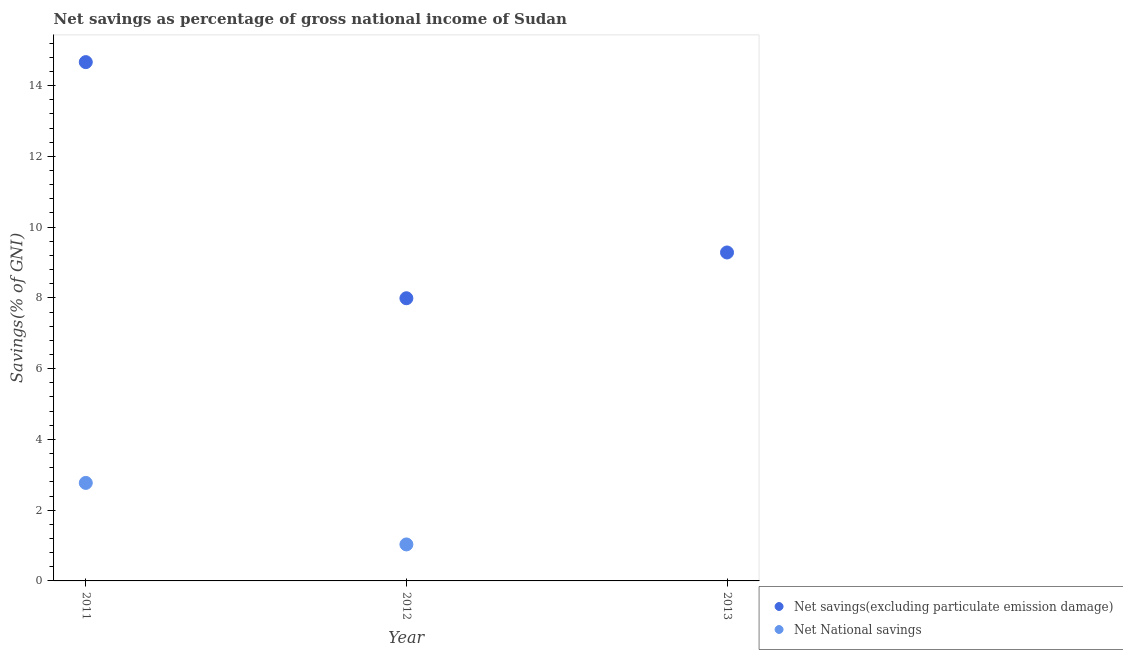What is the net national savings in 2013?
Keep it short and to the point. 0. Across all years, what is the maximum net savings(excluding particulate emission damage)?
Offer a very short reply. 14.66. Across all years, what is the minimum net savings(excluding particulate emission damage)?
Offer a terse response. 7.99. In which year was the net national savings maximum?
Make the answer very short. 2011. What is the total net national savings in the graph?
Your answer should be compact. 3.8. What is the difference between the net savings(excluding particulate emission damage) in 2011 and that in 2012?
Keep it short and to the point. 6.67. What is the difference between the net national savings in 2011 and the net savings(excluding particulate emission damage) in 2013?
Give a very brief answer. -6.51. What is the average net savings(excluding particulate emission damage) per year?
Your answer should be compact. 10.65. In the year 2012, what is the difference between the net savings(excluding particulate emission damage) and net national savings?
Your response must be concise. 6.96. In how many years, is the net national savings greater than 3.6 %?
Your answer should be very brief. 0. What is the ratio of the net savings(excluding particulate emission damage) in 2011 to that in 2012?
Your response must be concise. 1.84. Is the net national savings in 2011 less than that in 2012?
Provide a succinct answer. No. What is the difference between the highest and the second highest net savings(excluding particulate emission damage)?
Your answer should be very brief. 5.38. What is the difference between the highest and the lowest net national savings?
Your answer should be compact. 2.77. In how many years, is the net savings(excluding particulate emission damage) greater than the average net savings(excluding particulate emission damage) taken over all years?
Your answer should be very brief. 1. Is the sum of the net savings(excluding particulate emission damage) in 2011 and 2013 greater than the maximum net national savings across all years?
Offer a very short reply. Yes. Does the net national savings monotonically increase over the years?
Provide a short and direct response. No. Is the net savings(excluding particulate emission damage) strictly greater than the net national savings over the years?
Make the answer very short. Yes. Is the net national savings strictly less than the net savings(excluding particulate emission damage) over the years?
Provide a short and direct response. Yes. How many dotlines are there?
Your answer should be very brief. 2. How many years are there in the graph?
Provide a short and direct response. 3. What is the difference between two consecutive major ticks on the Y-axis?
Your answer should be compact. 2. Does the graph contain any zero values?
Offer a very short reply. Yes. Does the graph contain grids?
Make the answer very short. No. Where does the legend appear in the graph?
Offer a terse response. Bottom right. What is the title of the graph?
Offer a very short reply. Net savings as percentage of gross national income of Sudan. Does "Domestic liabilities" appear as one of the legend labels in the graph?
Ensure brevity in your answer.  No. What is the label or title of the X-axis?
Offer a terse response. Year. What is the label or title of the Y-axis?
Make the answer very short. Savings(% of GNI). What is the Savings(% of GNI) in Net savings(excluding particulate emission damage) in 2011?
Keep it short and to the point. 14.66. What is the Savings(% of GNI) of Net National savings in 2011?
Ensure brevity in your answer.  2.77. What is the Savings(% of GNI) in Net savings(excluding particulate emission damage) in 2012?
Provide a short and direct response. 7.99. What is the Savings(% of GNI) in Net National savings in 2012?
Provide a short and direct response. 1.03. What is the Savings(% of GNI) of Net savings(excluding particulate emission damage) in 2013?
Provide a succinct answer. 9.28. What is the Savings(% of GNI) of Net National savings in 2013?
Keep it short and to the point. 0. Across all years, what is the maximum Savings(% of GNI) of Net savings(excluding particulate emission damage)?
Your answer should be very brief. 14.66. Across all years, what is the maximum Savings(% of GNI) in Net National savings?
Provide a succinct answer. 2.77. Across all years, what is the minimum Savings(% of GNI) of Net savings(excluding particulate emission damage)?
Your answer should be compact. 7.99. What is the total Savings(% of GNI) of Net savings(excluding particulate emission damage) in the graph?
Give a very brief answer. 31.94. What is the total Savings(% of GNI) of Net National savings in the graph?
Give a very brief answer. 3.8. What is the difference between the Savings(% of GNI) of Net savings(excluding particulate emission damage) in 2011 and that in 2012?
Provide a short and direct response. 6.67. What is the difference between the Savings(% of GNI) of Net National savings in 2011 and that in 2012?
Offer a very short reply. 1.74. What is the difference between the Savings(% of GNI) in Net savings(excluding particulate emission damage) in 2011 and that in 2013?
Your answer should be compact. 5.38. What is the difference between the Savings(% of GNI) of Net savings(excluding particulate emission damage) in 2012 and that in 2013?
Provide a succinct answer. -1.29. What is the difference between the Savings(% of GNI) of Net savings(excluding particulate emission damage) in 2011 and the Savings(% of GNI) of Net National savings in 2012?
Your answer should be very brief. 13.63. What is the average Savings(% of GNI) of Net savings(excluding particulate emission damage) per year?
Your answer should be very brief. 10.65. What is the average Savings(% of GNI) in Net National savings per year?
Offer a terse response. 1.27. In the year 2011, what is the difference between the Savings(% of GNI) in Net savings(excluding particulate emission damage) and Savings(% of GNI) in Net National savings?
Make the answer very short. 11.89. In the year 2012, what is the difference between the Savings(% of GNI) of Net savings(excluding particulate emission damage) and Savings(% of GNI) of Net National savings?
Offer a terse response. 6.96. What is the ratio of the Savings(% of GNI) of Net savings(excluding particulate emission damage) in 2011 to that in 2012?
Offer a very short reply. 1.84. What is the ratio of the Savings(% of GNI) of Net National savings in 2011 to that in 2012?
Provide a short and direct response. 2.69. What is the ratio of the Savings(% of GNI) of Net savings(excluding particulate emission damage) in 2011 to that in 2013?
Your response must be concise. 1.58. What is the ratio of the Savings(% of GNI) in Net savings(excluding particulate emission damage) in 2012 to that in 2013?
Your answer should be compact. 0.86. What is the difference between the highest and the second highest Savings(% of GNI) of Net savings(excluding particulate emission damage)?
Ensure brevity in your answer.  5.38. What is the difference between the highest and the lowest Savings(% of GNI) of Net savings(excluding particulate emission damage)?
Keep it short and to the point. 6.67. What is the difference between the highest and the lowest Savings(% of GNI) of Net National savings?
Offer a terse response. 2.77. 